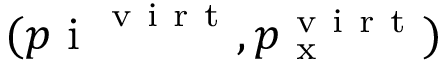Convert formula to latex. <formula><loc_0><loc_0><loc_500><loc_500>( p i ^ { v i r t } , p _ { x } ^ { v i r t } )</formula> 